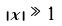Convert formula to latex. <formula><loc_0><loc_0><loc_500><loc_500>| x | \gg 1</formula> 